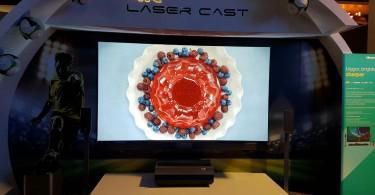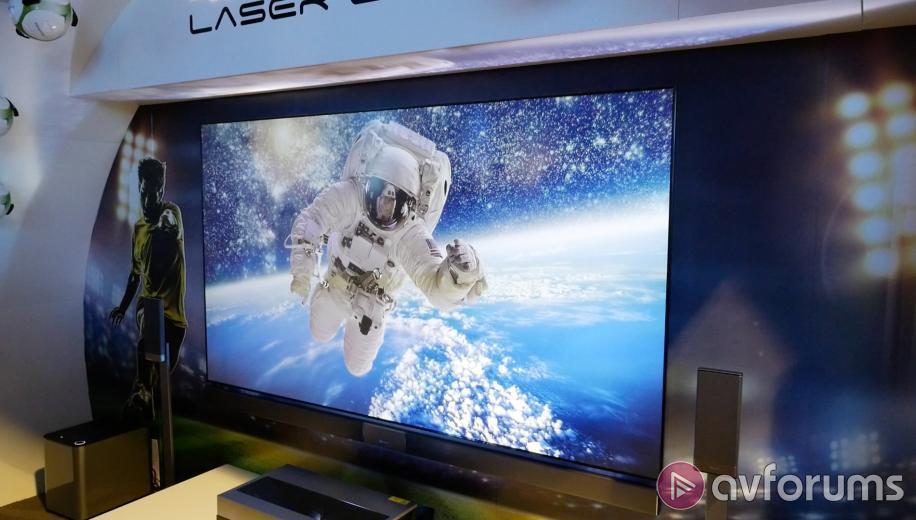The first image is the image on the left, the second image is the image on the right. Analyze the images presented: Is the assertion "The image in the right television display portrays a person." valid? Answer yes or no. Yes. The first image is the image on the left, the second image is the image on the right. Assess this claim about the two images: "One image shows an arch over a screen displaying a picture of red and blue berries around a shiny red rounded thing.". Correct or not? Answer yes or no. Yes. 